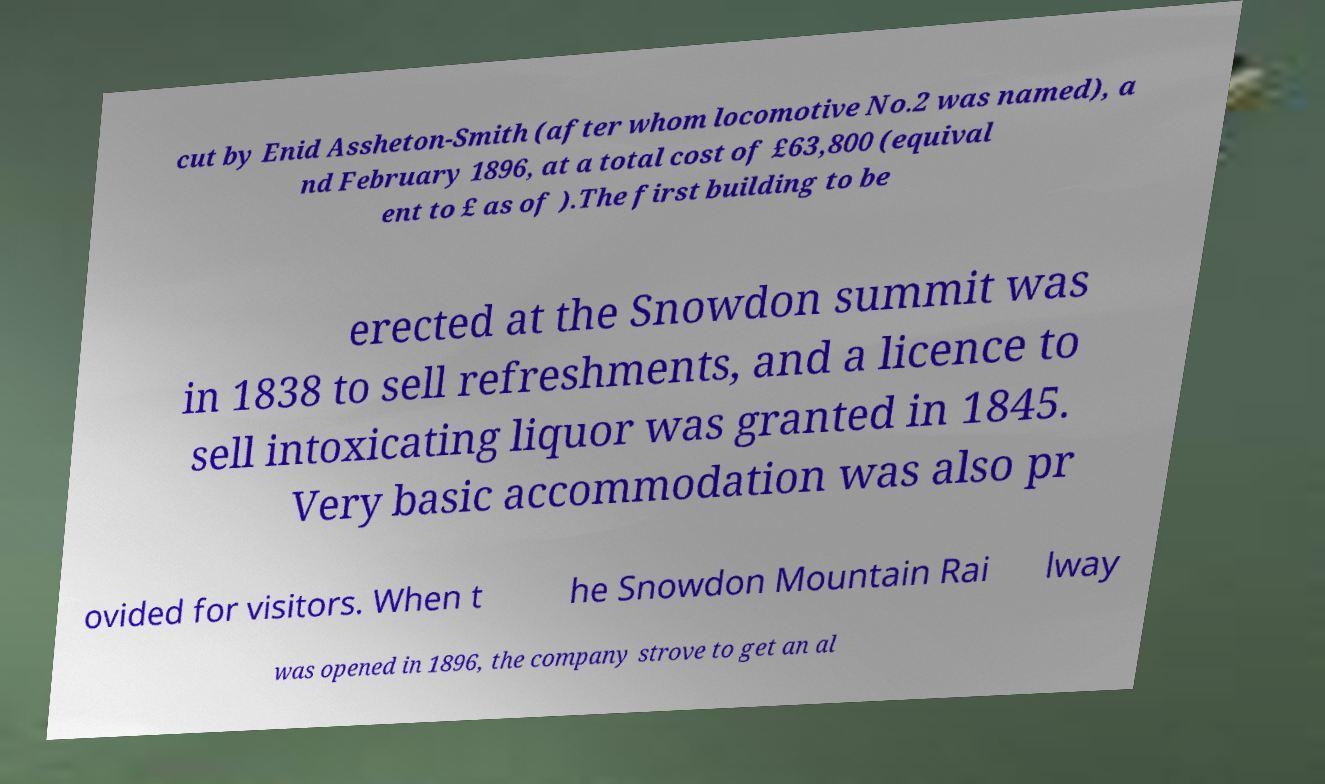There's text embedded in this image that I need extracted. Can you transcribe it verbatim? cut by Enid Assheton-Smith (after whom locomotive No.2 was named), a nd February 1896, at a total cost of £63,800 (equival ent to £ as of ).The first building to be erected at the Snowdon summit was in 1838 to sell refreshments, and a licence to sell intoxicating liquor was granted in 1845. Very basic accommodation was also pr ovided for visitors. When t he Snowdon Mountain Rai lway was opened in 1896, the company strove to get an al 